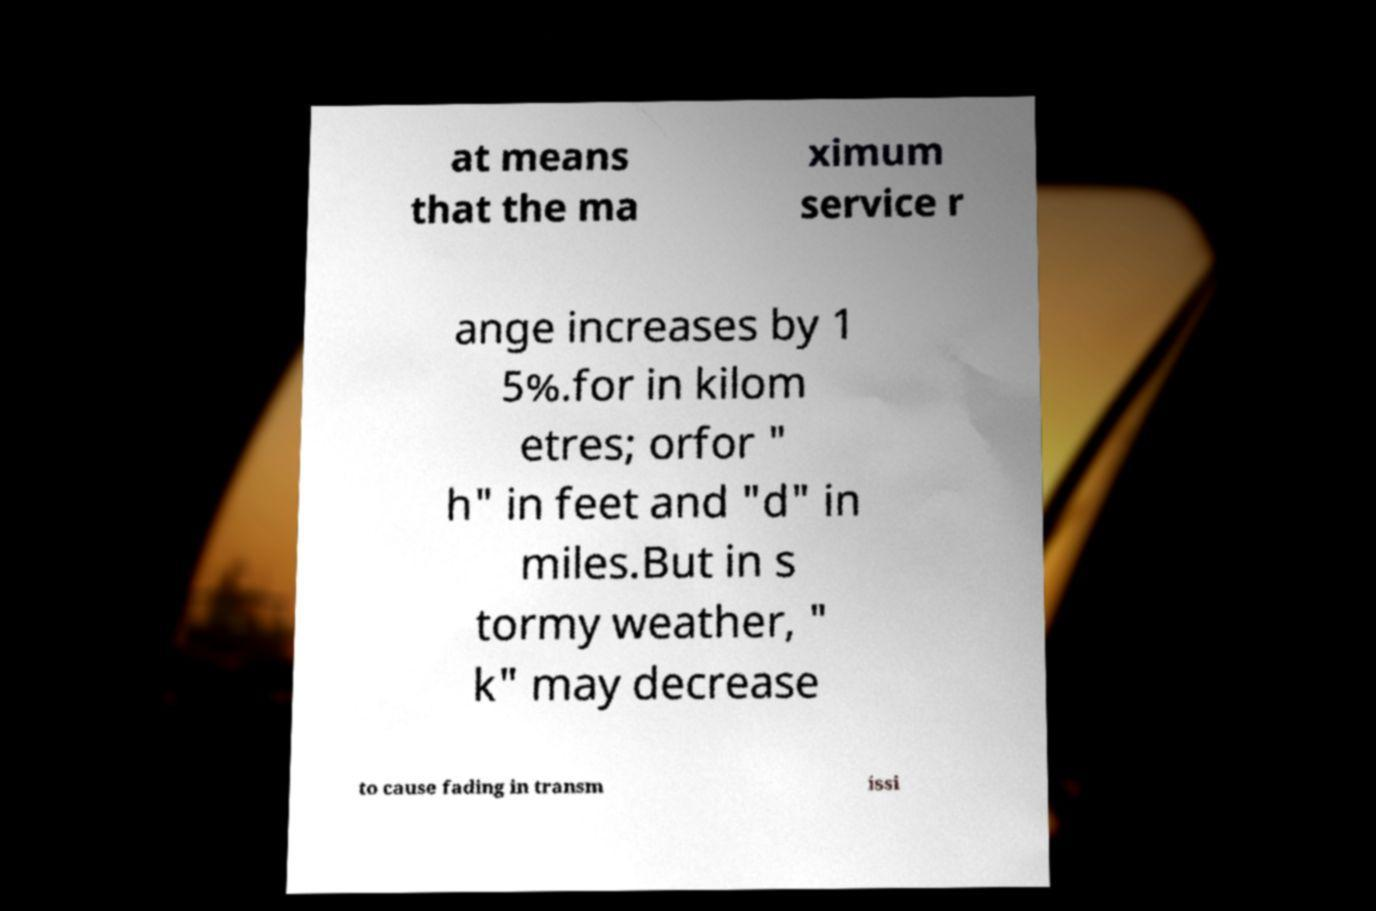What messages or text are displayed in this image? I need them in a readable, typed format. at means that the ma ximum service r ange increases by 1 5%.for in kilom etres; orfor " h" in feet and "d" in miles.But in s tormy weather, " k" may decrease to cause fading in transm issi 